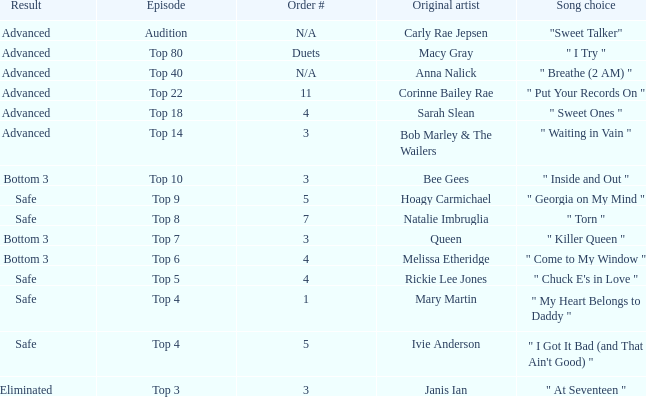What's the total number of songs originally performed by Anna Nalick? 1.0. 